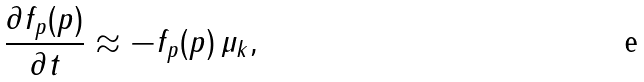<formula> <loc_0><loc_0><loc_500><loc_500>\frac { \partial f _ { p } ( p ) } { \partial t } \approx - f _ { p } ( p ) \, \mu _ { k } ,</formula> 